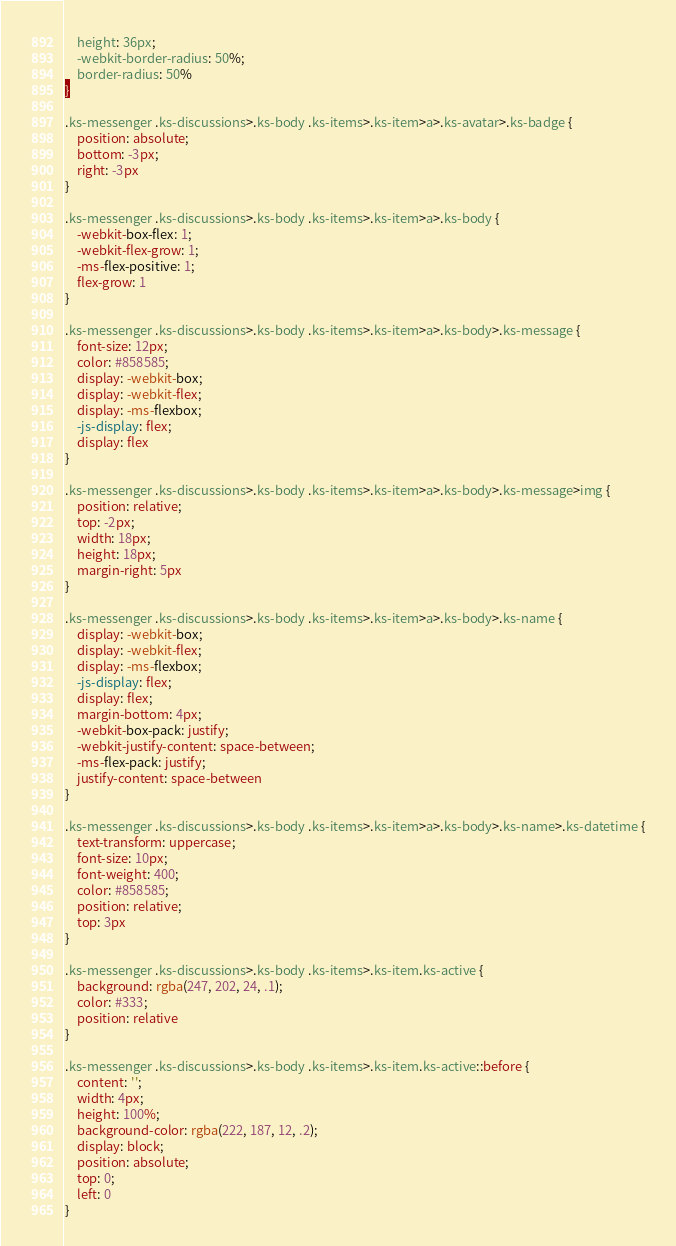<code> <loc_0><loc_0><loc_500><loc_500><_CSS_>    height: 36px;
    -webkit-border-radius: 50%;
    border-radius: 50%
}

.ks-messenger .ks-discussions>.ks-body .ks-items>.ks-item>a>.ks-avatar>.ks-badge {
    position: absolute;
    bottom: -3px;
    right: -3px
}

.ks-messenger .ks-discussions>.ks-body .ks-items>.ks-item>a>.ks-body {
    -webkit-box-flex: 1;
    -webkit-flex-grow: 1;
    -ms-flex-positive: 1;
    flex-grow: 1
}

.ks-messenger .ks-discussions>.ks-body .ks-items>.ks-item>a>.ks-body>.ks-message {
    font-size: 12px;
    color: #858585;
    display: -webkit-box;
    display: -webkit-flex;
    display: -ms-flexbox;
    -js-display: flex;
    display: flex
}

.ks-messenger .ks-discussions>.ks-body .ks-items>.ks-item>a>.ks-body>.ks-message>img {
    position: relative;
    top: -2px;
    width: 18px;
    height: 18px;
    margin-right: 5px
}

.ks-messenger .ks-discussions>.ks-body .ks-items>.ks-item>a>.ks-body>.ks-name {
    display: -webkit-box;
    display: -webkit-flex;
    display: -ms-flexbox;
    -js-display: flex;
    display: flex;
    margin-bottom: 4px;
    -webkit-box-pack: justify;
    -webkit-justify-content: space-between;
    -ms-flex-pack: justify;
    justify-content: space-between
}

.ks-messenger .ks-discussions>.ks-body .ks-items>.ks-item>a>.ks-body>.ks-name>.ks-datetime {
    text-transform: uppercase;
    font-size: 10px;
    font-weight: 400;
    color: #858585;
    position: relative;
    top: 3px
}

.ks-messenger .ks-discussions>.ks-body .ks-items>.ks-item.ks-active {
    background: rgba(247, 202, 24, .1);
    color: #333;
    position: relative
}

.ks-messenger .ks-discussions>.ks-body .ks-items>.ks-item.ks-active::before {
    content: '';
    width: 4px;
    height: 100%;
    background-color: rgba(222, 187, 12, .2);
    display: block;
    position: absolute;
    top: 0;
    left: 0
}</code> 